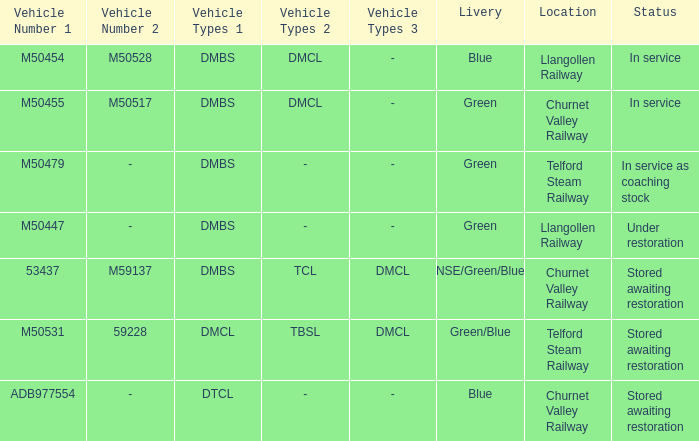What type of livery is being used as coaching stock in service? Green. 